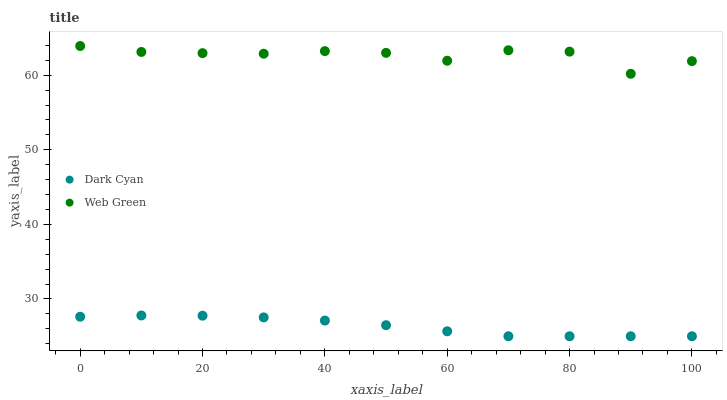Does Dark Cyan have the minimum area under the curve?
Answer yes or no. Yes. Does Web Green have the maximum area under the curve?
Answer yes or no. Yes. Does Web Green have the minimum area under the curve?
Answer yes or no. No. Is Dark Cyan the smoothest?
Answer yes or no. Yes. Is Web Green the roughest?
Answer yes or no. Yes. Is Web Green the smoothest?
Answer yes or no. No. Does Dark Cyan have the lowest value?
Answer yes or no. Yes. Does Web Green have the lowest value?
Answer yes or no. No. Does Web Green have the highest value?
Answer yes or no. Yes. Is Dark Cyan less than Web Green?
Answer yes or no. Yes. Is Web Green greater than Dark Cyan?
Answer yes or no. Yes. Does Dark Cyan intersect Web Green?
Answer yes or no. No. 